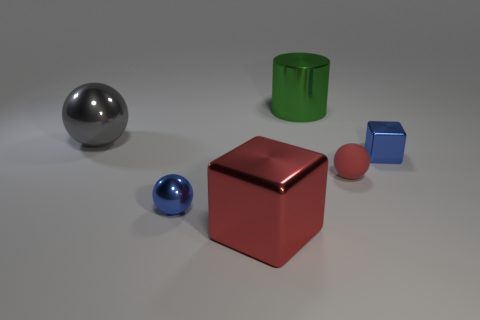Subtract all red spheres. How many spheres are left? 2 Add 3 metallic things. How many objects exist? 9 Subtract all cylinders. How many objects are left? 5 Subtract all purple spheres. Subtract all blue cylinders. How many spheres are left? 3 Subtract all small blue objects. Subtract all large red cubes. How many objects are left? 3 Add 4 big metallic cylinders. How many big metallic cylinders are left? 5 Add 6 large matte cylinders. How many large matte cylinders exist? 6 Subtract 0 purple blocks. How many objects are left? 6 